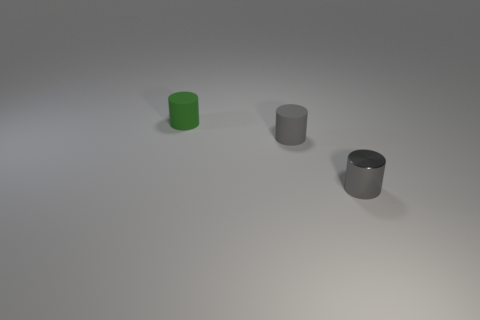Is the green object the same size as the metallic thing?
Keep it short and to the point. Yes. What number of objects are either small objects or tiny gray cylinders to the left of the shiny object?
Your answer should be compact. 3. There is a gray thing that is the same size as the gray shiny cylinder; what material is it?
Give a very brief answer. Rubber. The small cylinder that is to the right of the green object and to the left of the small metallic thing is made of what material?
Your answer should be compact. Rubber. Is there a small gray matte object that is in front of the small gray cylinder on the left side of the gray metallic object?
Your answer should be compact. No. What is the size of the object that is in front of the green rubber cylinder and to the left of the small shiny cylinder?
Provide a succinct answer. Small. How many red objects are shiny objects or small cylinders?
Offer a terse response. 0. What is the shape of the other metallic thing that is the same size as the green object?
Provide a short and direct response. Cylinder. How many other things are there of the same color as the tiny metallic object?
Your response must be concise. 1. There is a matte thing that is to the left of the gray cylinder that is behind the tiny gray metallic cylinder; what size is it?
Give a very brief answer. Small. 